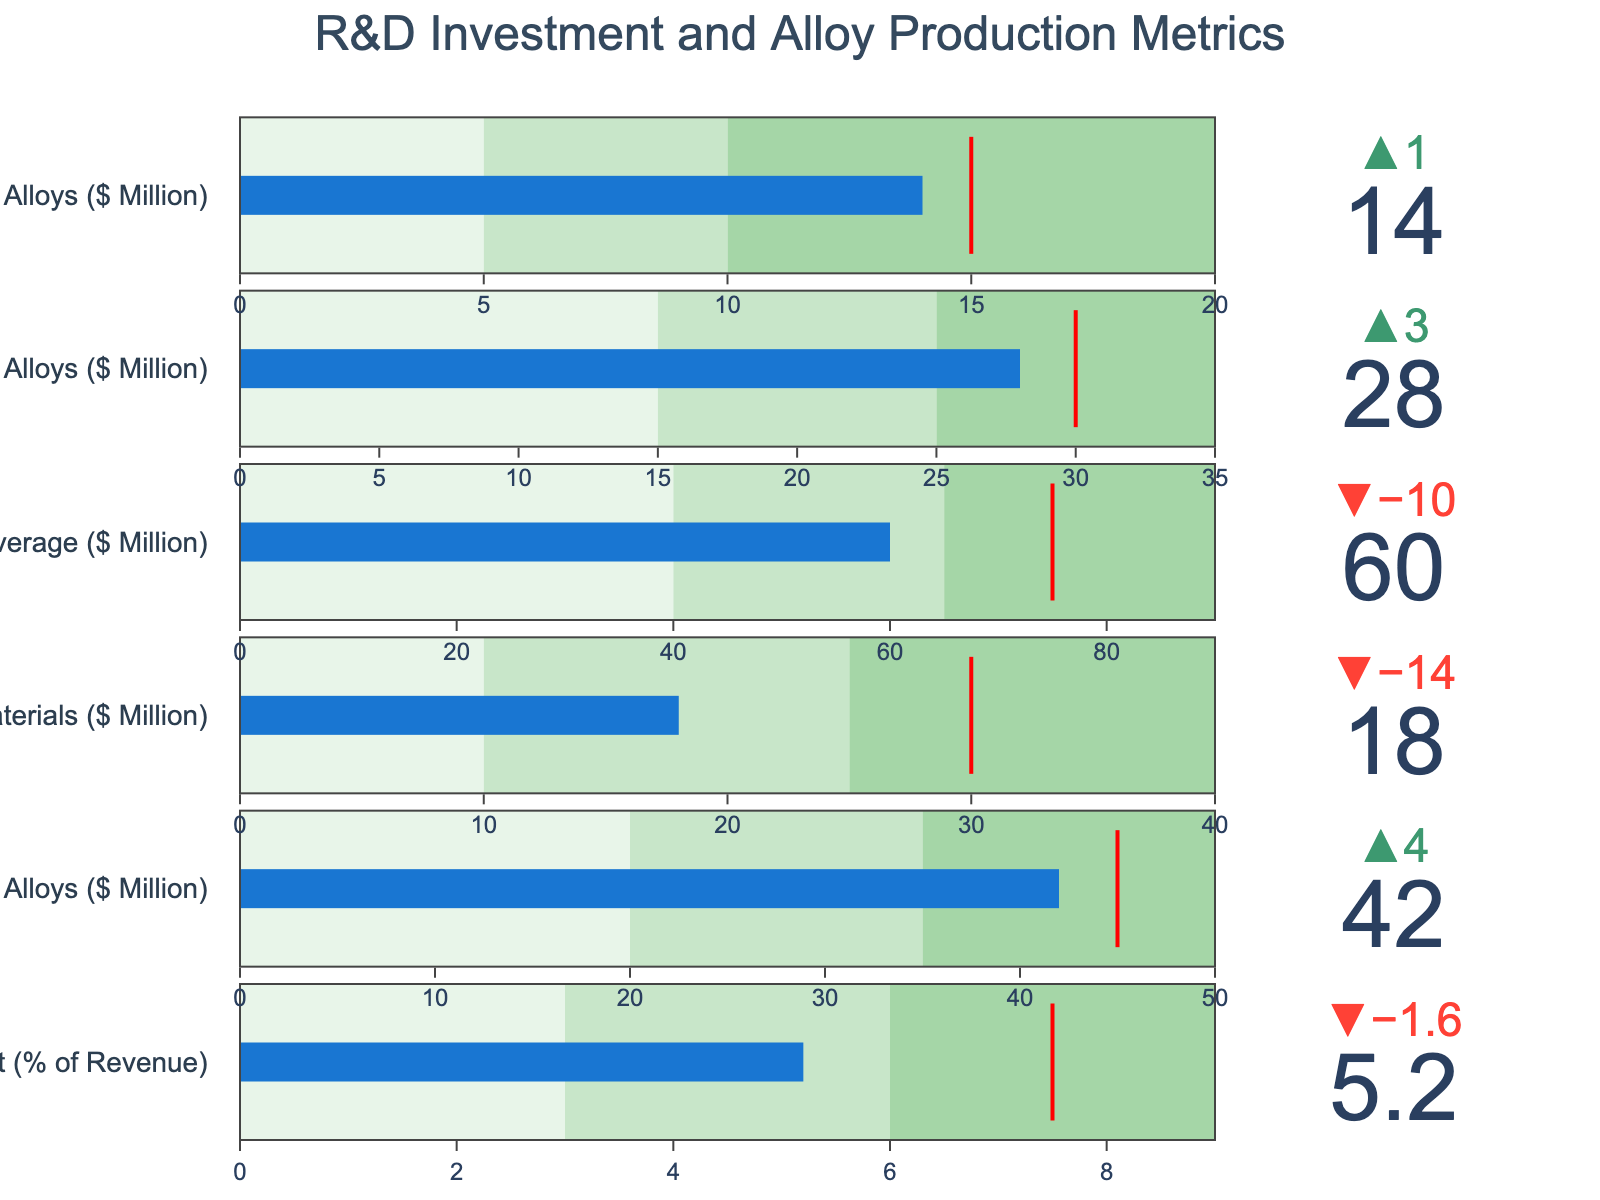What is the title of the figure? The title is typically placed at the top of the figure. In this case, the title "R&D Investment and Alloy Production Metrics" is visible at the top center.
Answer: R&D Investment and Alloy Production Metrics Which category has the highest actual value in millions of dollars? The actual values are displayed at the front of each bullet chart. For Traditional Alloys, Emerging Materials, and Industry Average, Traditional Alloys have the highest actual value at $42 million.
Answer: Traditional Alloys How does the actual R&D investment as a percentage of revenue compare to the target? The target is marked with a red line in bullet charts. The actual value for "R&D Investment (% of Revenue)" is 5.2%, and the target is 7.5%.
Answer: Below target Which category has the largest positive delta compared to its comparative value? The delta is the difference between the actual value and the comparative value, displayed at the top. Traditional Alloys have an actual value of $42 million and a comparative value of $38 million, giving a delta of +4 million, which is the largest positive delta among all categories.
Answer: Traditional Alloys Calculate the difference between the actual values of Steel Alloys and Aluminum Alloys. The actual values are 28 million for Steel Alloys and 14 million for Aluminum Alloys. Subtract the latter from the former: 28 - 14 = 14 million.
Answer: 14 million How many categories have actual values exceeding their targets? The target is shown by the red line in each category's bullet chart. By examining the actual values and comparing them to the targets, none of the categories exceed their targets.
Answer: 0 What is the comparative value for Emerging Materials? The comparative value is shown as a reference point at the top of each bullet chart. For Emerging Materials, it is $32 million.
Answer: $32 million Which category has an actual value falling within the second range (indicated by greener color)? The second range is the segment of bullet charts colored with a lighter green tone. For Traditional Alloys, the actual value of $42 million falls within this second range of $35 to $50 million.
Answer: Traditional Alloys What's the percentage difference between the industry average actual value and the comparative value? The actual for Industry Average is $60 million and the comparative is $70 million. The percentage difference is calculated as ((70 - 60) / 70) * 100 = 14.29%.
Answer: 14.29% Which two categories have the smallest difference between actual and target values? Calculate the differences for each category. For Traditional Alloys, the difference is 45 - 42 = 3 million, and for Aluminum Alloys, it’s 15 - 14 = 1 million. Subtracting these differences, Steel Alloys and Aluminum Alloys have the smallest difference of 2 and 1 million, respectively.
Answer: Steel Alloys and Aluminum Alloys 